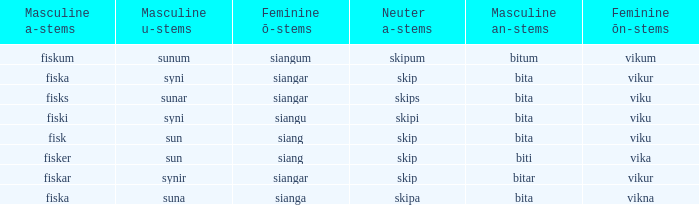What is the an-stem for the word which has an ö-stems of siangar and an u-stem ending of syni? Bita. 